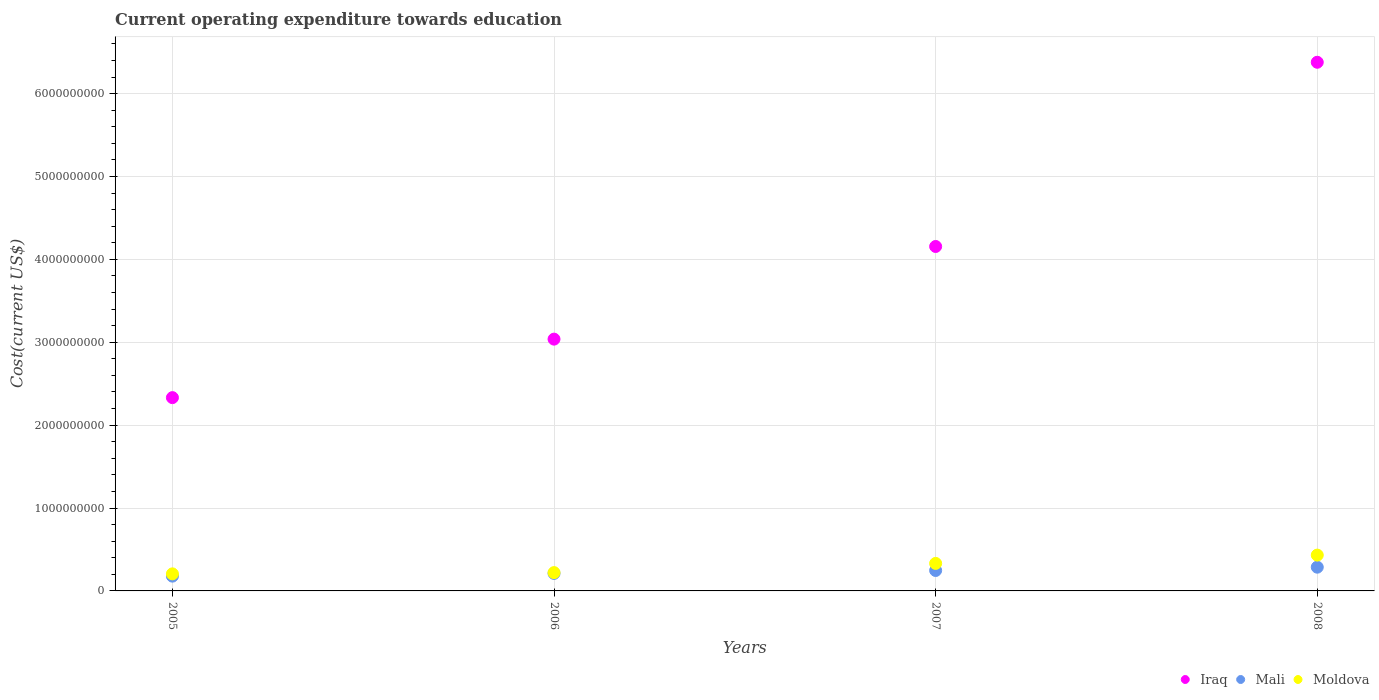How many different coloured dotlines are there?
Provide a short and direct response. 3. Is the number of dotlines equal to the number of legend labels?
Give a very brief answer. Yes. What is the expenditure towards education in Mali in 2006?
Offer a terse response. 2.11e+08. Across all years, what is the maximum expenditure towards education in Moldova?
Offer a very short reply. 4.32e+08. Across all years, what is the minimum expenditure towards education in Mali?
Your answer should be compact. 1.78e+08. In which year was the expenditure towards education in Moldova maximum?
Provide a short and direct response. 2008. What is the total expenditure towards education in Moldova in the graph?
Make the answer very short. 1.19e+09. What is the difference between the expenditure towards education in Moldova in 2005 and that in 2006?
Your response must be concise. -1.51e+07. What is the difference between the expenditure towards education in Mali in 2006 and the expenditure towards education in Moldova in 2008?
Your response must be concise. -2.21e+08. What is the average expenditure towards education in Mali per year?
Make the answer very short. 2.31e+08. In the year 2005, what is the difference between the expenditure towards education in Iraq and expenditure towards education in Moldova?
Give a very brief answer. 2.13e+09. In how many years, is the expenditure towards education in Moldova greater than 1800000000 US$?
Provide a succinct answer. 0. What is the ratio of the expenditure towards education in Mali in 2006 to that in 2008?
Provide a short and direct response. 0.74. Is the expenditure towards education in Iraq in 2007 less than that in 2008?
Keep it short and to the point. Yes. Is the difference between the expenditure towards education in Iraq in 2006 and 2008 greater than the difference between the expenditure towards education in Moldova in 2006 and 2008?
Provide a succinct answer. No. What is the difference between the highest and the second highest expenditure towards education in Moldova?
Your answer should be compact. 1.00e+08. What is the difference between the highest and the lowest expenditure towards education in Mali?
Your answer should be very brief. 1.08e+08. In how many years, is the expenditure towards education in Mali greater than the average expenditure towards education in Mali taken over all years?
Give a very brief answer. 2. Is it the case that in every year, the sum of the expenditure towards education in Iraq and expenditure towards education in Moldova  is greater than the expenditure towards education in Mali?
Provide a succinct answer. Yes. Does the graph contain grids?
Offer a very short reply. Yes. Where does the legend appear in the graph?
Keep it short and to the point. Bottom right. How many legend labels are there?
Provide a succinct answer. 3. What is the title of the graph?
Offer a very short reply. Current operating expenditure towards education. What is the label or title of the Y-axis?
Your answer should be compact. Cost(current US$). What is the Cost(current US$) of Iraq in 2005?
Provide a short and direct response. 2.33e+09. What is the Cost(current US$) of Mali in 2005?
Your answer should be compact. 1.78e+08. What is the Cost(current US$) of Moldova in 2005?
Keep it short and to the point. 2.06e+08. What is the Cost(current US$) in Iraq in 2006?
Give a very brief answer. 3.04e+09. What is the Cost(current US$) of Mali in 2006?
Provide a short and direct response. 2.11e+08. What is the Cost(current US$) of Moldova in 2006?
Your response must be concise. 2.21e+08. What is the Cost(current US$) of Iraq in 2007?
Provide a short and direct response. 4.16e+09. What is the Cost(current US$) in Mali in 2007?
Keep it short and to the point. 2.46e+08. What is the Cost(current US$) in Moldova in 2007?
Your response must be concise. 3.32e+08. What is the Cost(current US$) in Iraq in 2008?
Your answer should be compact. 6.38e+09. What is the Cost(current US$) of Mali in 2008?
Offer a very short reply. 2.86e+08. What is the Cost(current US$) of Moldova in 2008?
Offer a very short reply. 4.32e+08. Across all years, what is the maximum Cost(current US$) of Iraq?
Offer a terse response. 6.38e+09. Across all years, what is the maximum Cost(current US$) of Mali?
Keep it short and to the point. 2.86e+08. Across all years, what is the maximum Cost(current US$) of Moldova?
Your answer should be compact. 4.32e+08. Across all years, what is the minimum Cost(current US$) of Iraq?
Make the answer very short. 2.33e+09. Across all years, what is the minimum Cost(current US$) in Mali?
Your answer should be very brief. 1.78e+08. Across all years, what is the minimum Cost(current US$) in Moldova?
Provide a succinct answer. 2.06e+08. What is the total Cost(current US$) in Iraq in the graph?
Give a very brief answer. 1.59e+1. What is the total Cost(current US$) of Mali in the graph?
Your answer should be compact. 9.23e+08. What is the total Cost(current US$) in Moldova in the graph?
Your answer should be very brief. 1.19e+09. What is the difference between the Cost(current US$) of Iraq in 2005 and that in 2006?
Ensure brevity in your answer.  -7.06e+08. What is the difference between the Cost(current US$) of Mali in 2005 and that in 2006?
Give a very brief answer. -3.27e+07. What is the difference between the Cost(current US$) of Moldova in 2005 and that in 2006?
Your response must be concise. -1.51e+07. What is the difference between the Cost(current US$) in Iraq in 2005 and that in 2007?
Give a very brief answer. -1.82e+09. What is the difference between the Cost(current US$) in Mali in 2005 and that in 2007?
Give a very brief answer. -6.80e+07. What is the difference between the Cost(current US$) of Moldova in 2005 and that in 2007?
Offer a terse response. -1.26e+08. What is the difference between the Cost(current US$) of Iraq in 2005 and that in 2008?
Keep it short and to the point. -4.05e+09. What is the difference between the Cost(current US$) of Mali in 2005 and that in 2008?
Make the answer very short. -1.08e+08. What is the difference between the Cost(current US$) in Moldova in 2005 and that in 2008?
Your response must be concise. -2.26e+08. What is the difference between the Cost(current US$) in Iraq in 2006 and that in 2007?
Ensure brevity in your answer.  -1.12e+09. What is the difference between the Cost(current US$) in Mali in 2006 and that in 2007?
Offer a terse response. -3.53e+07. What is the difference between the Cost(current US$) in Moldova in 2006 and that in 2007?
Keep it short and to the point. -1.11e+08. What is the difference between the Cost(current US$) in Iraq in 2006 and that in 2008?
Your response must be concise. -3.34e+09. What is the difference between the Cost(current US$) in Mali in 2006 and that in 2008?
Offer a terse response. -7.53e+07. What is the difference between the Cost(current US$) in Moldova in 2006 and that in 2008?
Give a very brief answer. -2.11e+08. What is the difference between the Cost(current US$) of Iraq in 2007 and that in 2008?
Offer a terse response. -2.22e+09. What is the difference between the Cost(current US$) in Mali in 2007 and that in 2008?
Give a very brief answer. -4.00e+07. What is the difference between the Cost(current US$) of Moldova in 2007 and that in 2008?
Your answer should be compact. -1.00e+08. What is the difference between the Cost(current US$) in Iraq in 2005 and the Cost(current US$) in Mali in 2006?
Offer a very short reply. 2.12e+09. What is the difference between the Cost(current US$) of Iraq in 2005 and the Cost(current US$) of Moldova in 2006?
Provide a succinct answer. 2.11e+09. What is the difference between the Cost(current US$) of Mali in 2005 and the Cost(current US$) of Moldova in 2006?
Your response must be concise. -4.25e+07. What is the difference between the Cost(current US$) in Iraq in 2005 and the Cost(current US$) in Mali in 2007?
Offer a very short reply. 2.09e+09. What is the difference between the Cost(current US$) of Iraq in 2005 and the Cost(current US$) of Moldova in 2007?
Provide a short and direct response. 2.00e+09. What is the difference between the Cost(current US$) of Mali in 2005 and the Cost(current US$) of Moldova in 2007?
Your answer should be very brief. -1.54e+08. What is the difference between the Cost(current US$) of Iraq in 2005 and the Cost(current US$) of Mali in 2008?
Provide a short and direct response. 2.05e+09. What is the difference between the Cost(current US$) of Iraq in 2005 and the Cost(current US$) of Moldova in 2008?
Your response must be concise. 1.90e+09. What is the difference between the Cost(current US$) of Mali in 2005 and the Cost(current US$) of Moldova in 2008?
Provide a succinct answer. -2.54e+08. What is the difference between the Cost(current US$) of Iraq in 2006 and the Cost(current US$) of Mali in 2007?
Provide a succinct answer. 2.79e+09. What is the difference between the Cost(current US$) in Iraq in 2006 and the Cost(current US$) in Moldova in 2007?
Your response must be concise. 2.71e+09. What is the difference between the Cost(current US$) of Mali in 2006 and the Cost(current US$) of Moldova in 2007?
Provide a succinct answer. -1.21e+08. What is the difference between the Cost(current US$) in Iraq in 2006 and the Cost(current US$) in Mali in 2008?
Ensure brevity in your answer.  2.75e+09. What is the difference between the Cost(current US$) of Iraq in 2006 and the Cost(current US$) of Moldova in 2008?
Your answer should be compact. 2.61e+09. What is the difference between the Cost(current US$) in Mali in 2006 and the Cost(current US$) in Moldova in 2008?
Provide a succinct answer. -2.21e+08. What is the difference between the Cost(current US$) in Iraq in 2007 and the Cost(current US$) in Mali in 2008?
Offer a very short reply. 3.87e+09. What is the difference between the Cost(current US$) of Iraq in 2007 and the Cost(current US$) of Moldova in 2008?
Ensure brevity in your answer.  3.72e+09. What is the difference between the Cost(current US$) in Mali in 2007 and the Cost(current US$) in Moldova in 2008?
Offer a very short reply. -1.86e+08. What is the average Cost(current US$) of Iraq per year?
Offer a very short reply. 3.98e+09. What is the average Cost(current US$) of Mali per year?
Offer a very short reply. 2.31e+08. What is the average Cost(current US$) of Moldova per year?
Your answer should be compact. 2.98e+08. In the year 2005, what is the difference between the Cost(current US$) in Iraq and Cost(current US$) in Mali?
Your response must be concise. 2.15e+09. In the year 2005, what is the difference between the Cost(current US$) in Iraq and Cost(current US$) in Moldova?
Your answer should be compact. 2.13e+09. In the year 2005, what is the difference between the Cost(current US$) in Mali and Cost(current US$) in Moldova?
Keep it short and to the point. -2.74e+07. In the year 2006, what is the difference between the Cost(current US$) of Iraq and Cost(current US$) of Mali?
Your response must be concise. 2.83e+09. In the year 2006, what is the difference between the Cost(current US$) of Iraq and Cost(current US$) of Moldova?
Give a very brief answer. 2.82e+09. In the year 2006, what is the difference between the Cost(current US$) of Mali and Cost(current US$) of Moldova?
Offer a terse response. -9.82e+06. In the year 2007, what is the difference between the Cost(current US$) of Iraq and Cost(current US$) of Mali?
Give a very brief answer. 3.91e+09. In the year 2007, what is the difference between the Cost(current US$) in Iraq and Cost(current US$) in Moldova?
Offer a very short reply. 3.82e+09. In the year 2007, what is the difference between the Cost(current US$) of Mali and Cost(current US$) of Moldova?
Give a very brief answer. -8.55e+07. In the year 2008, what is the difference between the Cost(current US$) in Iraq and Cost(current US$) in Mali?
Provide a short and direct response. 6.09e+09. In the year 2008, what is the difference between the Cost(current US$) in Iraq and Cost(current US$) in Moldova?
Your response must be concise. 5.95e+09. In the year 2008, what is the difference between the Cost(current US$) in Mali and Cost(current US$) in Moldova?
Keep it short and to the point. -1.46e+08. What is the ratio of the Cost(current US$) in Iraq in 2005 to that in 2006?
Ensure brevity in your answer.  0.77. What is the ratio of the Cost(current US$) in Mali in 2005 to that in 2006?
Your answer should be compact. 0.85. What is the ratio of the Cost(current US$) of Moldova in 2005 to that in 2006?
Your answer should be very brief. 0.93. What is the ratio of the Cost(current US$) of Iraq in 2005 to that in 2007?
Your answer should be compact. 0.56. What is the ratio of the Cost(current US$) of Mali in 2005 to that in 2007?
Your answer should be very brief. 0.72. What is the ratio of the Cost(current US$) of Moldova in 2005 to that in 2007?
Keep it short and to the point. 0.62. What is the ratio of the Cost(current US$) of Iraq in 2005 to that in 2008?
Provide a succinct answer. 0.37. What is the ratio of the Cost(current US$) of Mali in 2005 to that in 2008?
Ensure brevity in your answer.  0.62. What is the ratio of the Cost(current US$) in Moldova in 2005 to that in 2008?
Your answer should be compact. 0.48. What is the ratio of the Cost(current US$) of Iraq in 2006 to that in 2007?
Give a very brief answer. 0.73. What is the ratio of the Cost(current US$) of Mali in 2006 to that in 2007?
Provide a succinct answer. 0.86. What is the ratio of the Cost(current US$) of Moldova in 2006 to that in 2007?
Make the answer very short. 0.67. What is the ratio of the Cost(current US$) of Iraq in 2006 to that in 2008?
Offer a terse response. 0.48. What is the ratio of the Cost(current US$) of Mali in 2006 to that in 2008?
Provide a short and direct response. 0.74. What is the ratio of the Cost(current US$) in Moldova in 2006 to that in 2008?
Ensure brevity in your answer.  0.51. What is the ratio of the Cost(current US$) of Iraq in 2007 to that in 2008?
Ensure brevity in your answer.  0.65. What is the ratio of the Cost(current US$) in Mali in 2007 to that in 2008?
Your answer should be very brief. 0.86. What is the ratio of the Cost(current US$) in Moldova in 2007 to that in 2008?
Offer a terse response. 0.77. What is the difference between the highest and the second highest Cost(current US$) of Iraq?
Offer a very short reply. 2.22e+09. What is the difference between the highest and the second highest Cost(current US$) of Mali?
Your response must be concise. 4.00e+07. What is the difference between the highest and the second highest Cost(current US$) in Moldova?
Provide a succinct answer. 1.00e+08. What is the difference between the highest and the lowest Cost(current US$) of Iraq?
Make the answer very short. 4.05e+09. What is the difference between the highest and the lowest Cost(current US$) of Mali?
Give a very brief answer. 1.08e+08. What is the difference between the highest and the lowest Cost(current US$) in Moldova?
Offer a terse response. 2.26e+08. 